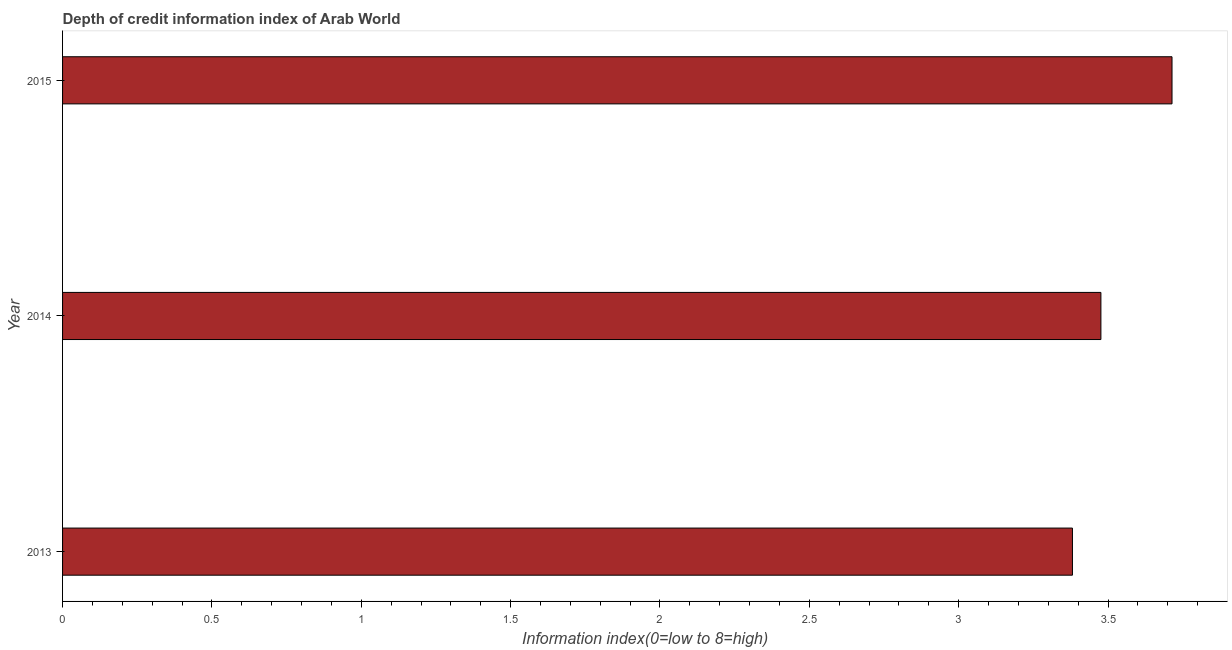Does the graph contain grids?
Provide a succinct answer. No. What is the title of the graph?
Provide a succinct answer. Depth of credit information index of Arab World. What is the label or title of the X-axis?
Your answer should be very brief. Information index(0=low to 8=high). What is the depth of credit information index in 2013?
Make the answer very short. 3.38. Across all years, what is the maximum depth of credit information index?
Make the answer very short. 3.71. Across all years, what is the minimum depth of credit information index?
Your answer should be very brief. 3.38. In which year was the depth of credit information index maximum?
Ensure brevity in your answer.  2015. What is the sum of the depth of credit information index?
Your response must be concise. 10.57. What is the difference between the depth of credit information index in 2014 and 2015?
Offer a terse response. -0.24. What is the average depth of credit information index per year?
Offer a terse response. 3.52. What is the median depth of credit information index?
Your answer should be very brief. 3.48. In how many years, is the depth of credit information index greater than 2.5 ?
Provide a short and direct response. 3. Do a majority of the years between 2014 and 2013 (inclusive) have depth of credit information index greater than 1.2 ?
Provide a succinct answer. No. Is the depth of credit information index in 2013 less than that in 2014?
Provide a short and direct response. Yes. What is the difference between the highest and the second highest depth of credit information index?
Offer a terse response. 0.24. Is the sum of the depth of credit information index in 2013 and 2015 greater than the maximum depth of credit information index across all years?
Provide a succinct answer. Yes. What is the difference between the highest and the lowest depth of credit information index?
Make the answer very short. 0.33. What is the difference between two consecutive major ticks on the X-axis?
Ensure brevity in your answer.  0.5. What is the Information index(0=low to 8=high) in 2013?
Your answer should be compact. 3.38. What is the Information index(0=low to 8=high) of 2014?
Your response must be concise. 3.48. What is the Information index(0=low to 8=high) of 2015?
Provide a succinct answer. 3.71. What is the difference between the Information index(0=low to 8=high) in 2013 and 2014?
Keep it short and to the point. -0.1. What is the difference between the Information index(0=low to 8=high) in 2013 and 2015?
Provide a short and direct response. -0.33. What is the difference between the Information index(0=low to 8=high) in 2014 and 2015?
Ensure brevity in your answer.  -0.24. What is the ratio of the Information index(0=low to 8=high) in 2013 to that in 2015?
Your answer should be compact. 0.91. What is the ratio of the Information index(0=low to 8=high) in 2014 to that in 2015?
Your answer should be very brief. 0.94. 